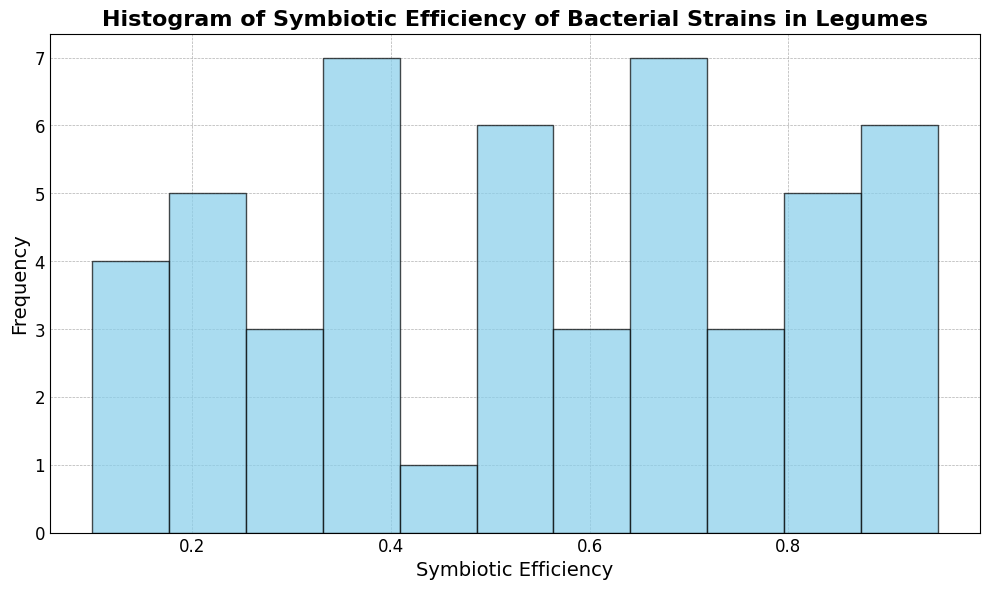What range of Symbiotic Efficiency is most common among the legume samples? By looking at the histogram, identify the bin with the highest bar to determine the most common range of Symbiotic Efficiency.
Answer: 0.4 - 0.5 How many samples fall within the Symbiotic Efficiency range of 0.7 to 0.8? Identify the height of the bar corresponding to the 0.7 to 0.8 range on the histogram.
Answer: 4 Which Symbiotic Efficiency range has the least number of legume samples? Identify the bin (range) with the lowest bar height in the histogram.
Answer: 0.9 - 1.0 Compare the number of samples with Symbiotic Efficiency below 0.3 and those above 0.8. Which range has more samples? Count the bars for the ranges 0.0 - 0.3 and compare them with the sum of the bars for the ranges 0.8 - 1.0 in the histogram.
Answer: Below 0.3 Is the frequency distribution of Symbiotic Efficiency skewed towards lower or higher efficiency ranges? Observe the overall shape of the histogram to determine if there are more bars (samples) on the lower or higher end.
Answer: Higher efficiency ranges What is the approximate midpoint (median) range of Symbiotic Efficiency for the legume samples? Locate the range around which half of the samples have lower efficiency, and half have higher efficiency. The midpoint bar in a symmetric distribution often helps to find the median.
Answer: 0.5 - 0.6 How does the frequency of Symbiotic Efficiency in the 0.2 - 0.3 range compare to that in the 0.6 - 0.7 range? Compare the heights of the bars for the 0.2 - 0.3 range and the 0.6 - 0.7 range to see which bar is taller.
Answer: 0.6 - 0.7 range is higher Considering the bins, what is the average bin frequency across the histogram? Sum the heights of all bins and divide by the number of bins (12) to find the average frequency.
Answer: 4.17 Are there any bins with Symbiotic Efficiency where no legume samples are present? Check if there is any bin with a height of 0 on the histogram.
Answer: No 